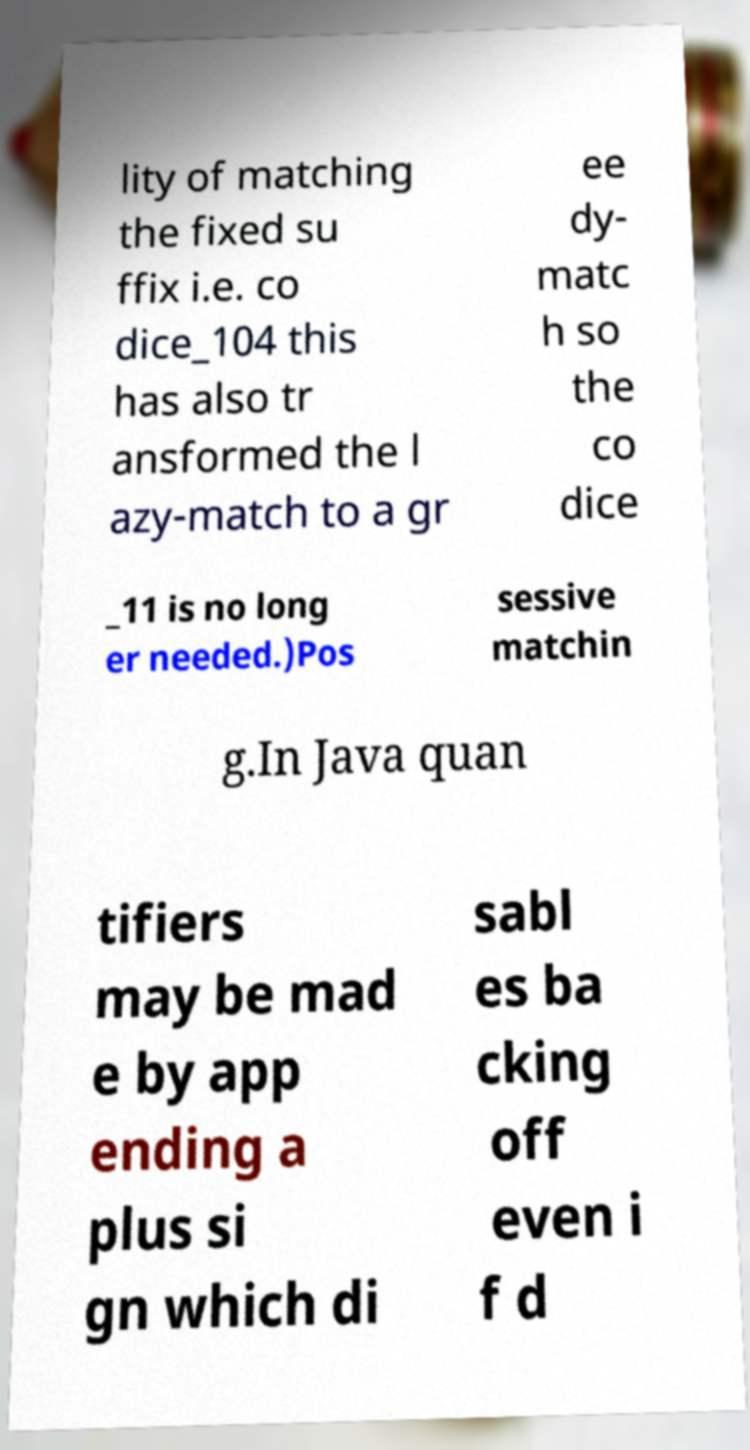Please identify and transcribe the text found in this image. lity of matching the fixed su ffix i.e. co dice_104 this has also tr ansformed the l azy-match to a gr ee dy- matc h so the co dice _11 is no long er needed.)Pos sessive matchin g.In Java quan tifiers may be mad e by app ending a plus si gn which di sabl es ba cking off even i f d 